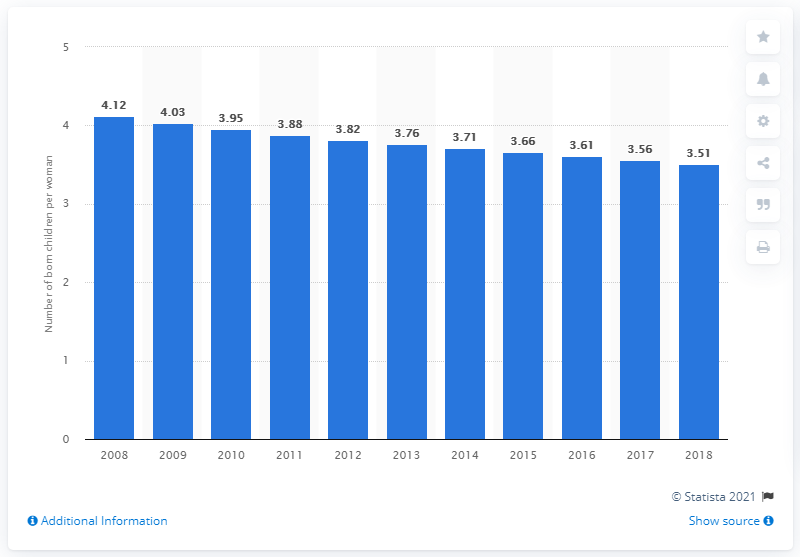Specify some key components in this picture. In 2018, Pakistan's fertility rate was 3.51. 